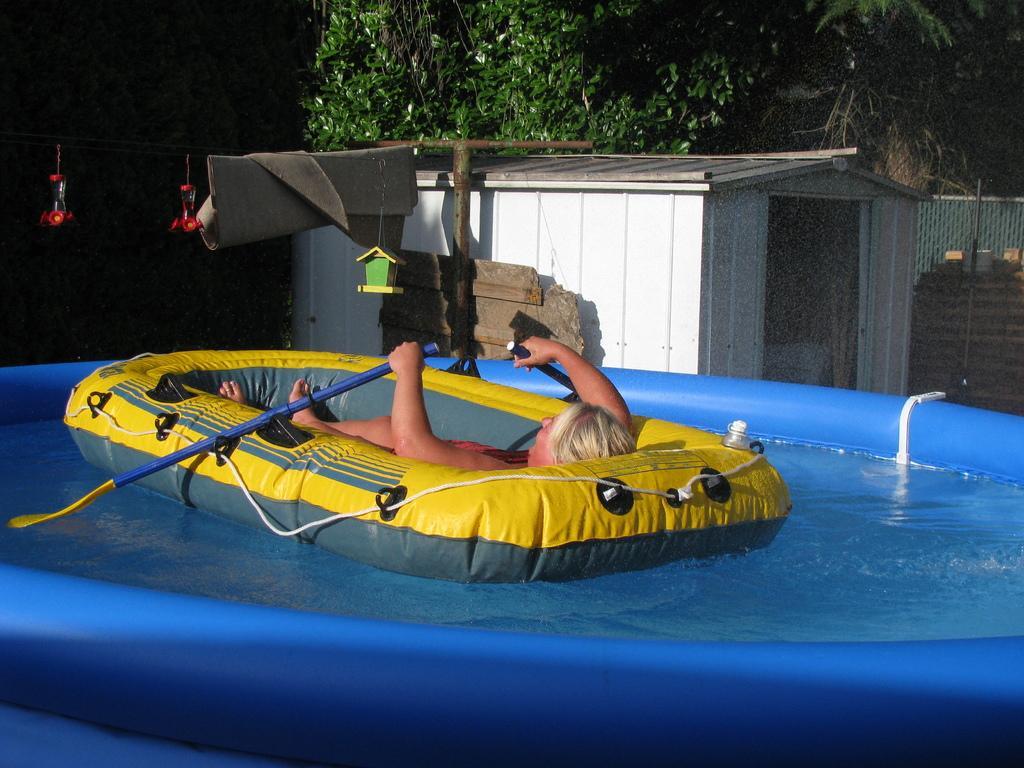Could you give a brief overview of what you see in this image? In this image there is a person in the swimming bed, the swimming bed is in the pool, a booth, a fence, trees, few objects hanging to a rope and a white color folded banner. 